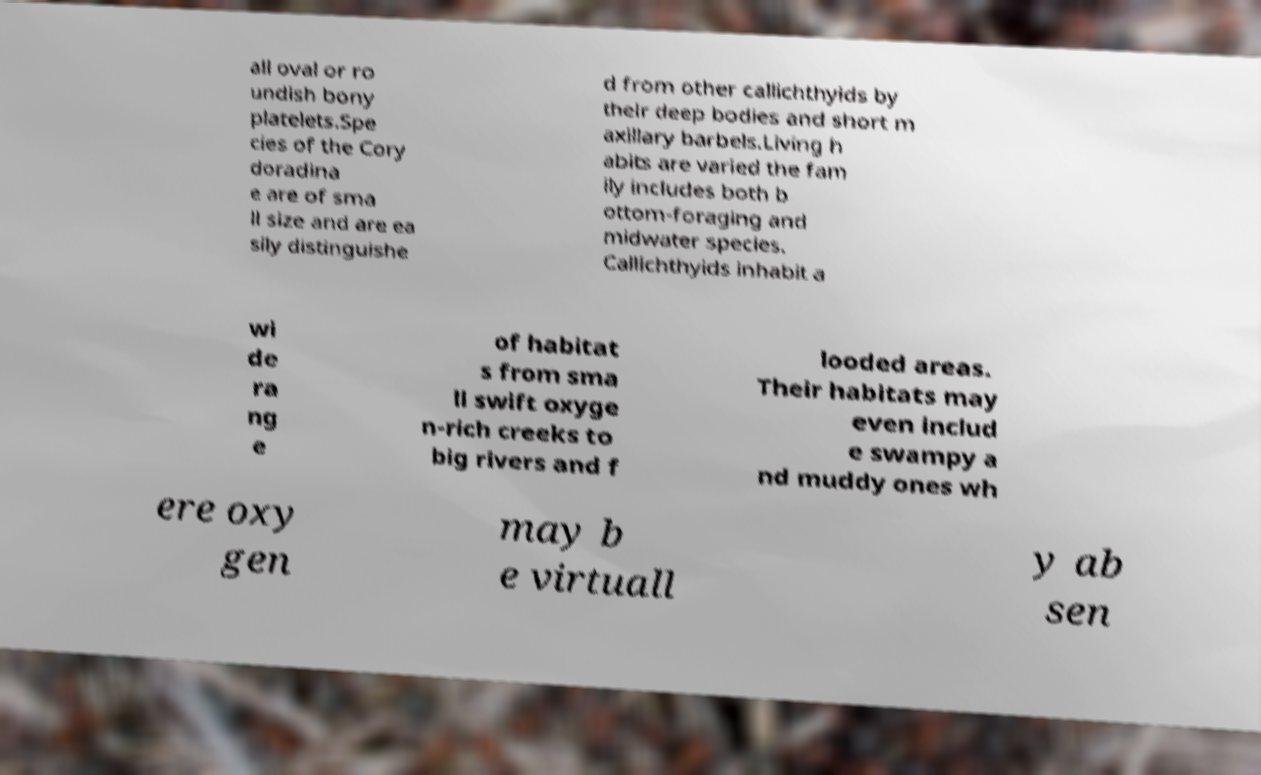Can you accurately transcribe the text from the provided image for me? all oval or ro undish bony platelets.Spe cies of the Cory doradina e are of sma ll size and are ea sily distinguishe d from other callichthyids by their deep bodies and short m axillary barbels.Living h abits are varied the fam ily includes both b ottom-foraging and midwater species. Callichthyids inhabit a wi de ra ng e of habitat s from sma ll swift oxyge n-rich creeks to big rivers and f looded areas. Their habitats may even includ e swampy a nd muddy ones wh ere oxy gen may b e virtuall y ab sen 